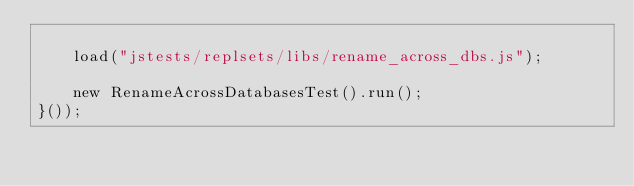Convert code to text. <code><loc_0><loc_0><loc_500><loc_500><_JavaScript_>
    load("jstests/replsets/libs/rename_across_dbs.js");

    new RenameAcrossDatabasesTest().run();
}());
</code> 